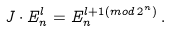Convert formula to latex. <formula><loc_0><loc_0><loc_500><loc_500>J \cdot E ^ { l } _ { n } = E ^ { l + 1 ( m o d \, 2 ^ { n } ) } _ { n } \, .</formula> 